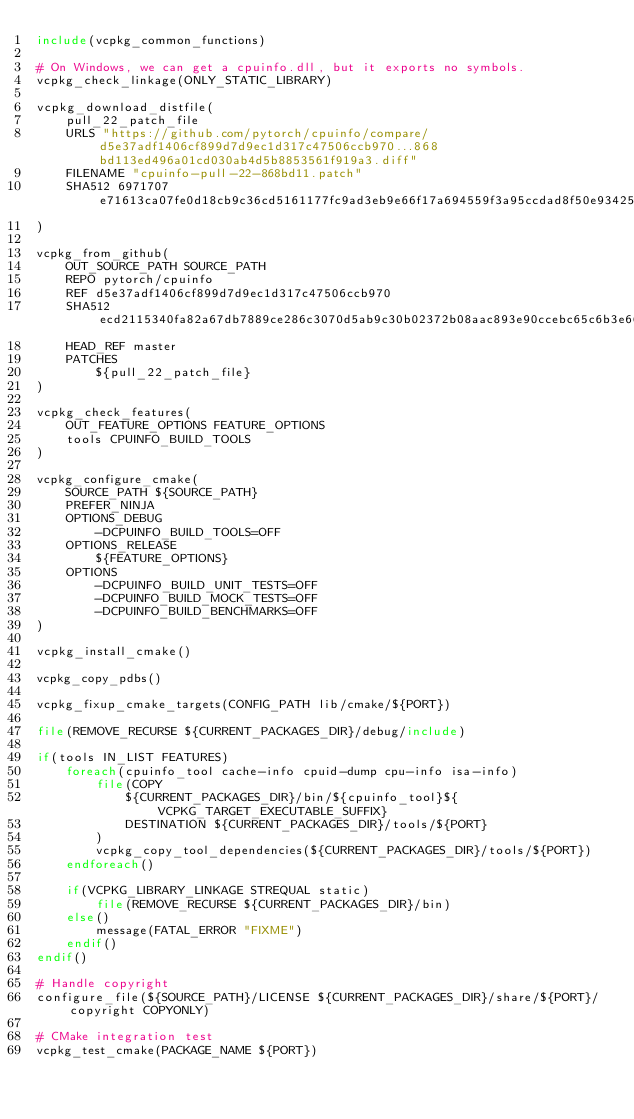Convert code to text. <code><loc_0><loc_0><loc_500><loc_500><_CMake_>include(vcpkg_common_functions)

# On Windows, we can get a cpuinfo.dll, but it exports no symbols.
vcpkg_check_linkage(ONLY_STATIC_LIBRARY)

vcpkg_download_distfile(
    pull_22_patch_file
    URLS "https://github.com/pytorch/cpuinfo/compare/d5e37adf1406cf899d7d9ec1d317c47506ccb970...868bd113ed496a01cd030ab4d5b8853561f919a3.diff"
    FILENAME "cpuinfo-pull-22-868bd11.patch"
    SHA512 6971707e71613ca07fe0d18cb9c36cd5161177fc9ad3eb9e66f17a694559f3a95ccdad8f50e9342507a7978bd454f66e47c8a94db9077267ca302535b7cc3b59
)

vcpkg_from_github(
    OUT_SOURCE_PATH SOURCE_PATH
    REPO pytorch/cpuinfo
    REF d5e37adf1406cf899d7d9ec1d317c47506ccb970
    SHA512 ecd2115340fa82a67db7889ce286c3070d5ab9c30b02372b08aac893e90ccebc65c6b3e66aa02a9ae9c57892d2d8c3b77cb836e5fc3b88df2c75d33e574d90d2
    HEAD_REF master
    PATCHES
        ${pull_22_patch_file}
)

vcpkg_check_features(
    OUT_FEATURE_OPTIONS FEATURE_OPTIONS
    tools CPUINFO_BUILD_TOOLS
)

vcpkg_configure_cmake(
    SOURCE_PATH ${SOURCE_PATH}
    PREFER_NINJA
    OPTIONS_DEBUG
        -DCPUINFO_BUILD_TOOLS=OFF
    OPTIONS_RELEASE
        ${FEATURE_OPTIONS}
    OPTIONS
        -DCPUINFO_BUILD_UNIT_TESTS=OFF
        -DCPUINFO_BUILD_MOCK_TESTS=OFF
        -DCPUINFO_BUILD_BENCHMARKS=OFF
)

vcpkg_install_cmake()

vcpkg_copy_pdbs()

vcpkg_fixup_cmake_targets(CONFIG_PATH lib/cmake/${PORT})

file(REMOVE_RECURSE ${CURRENT_PACKAGES_DIR}/debug/include)

if(tools IN_LIST FEATURES)
    foreach(cpuinfo_tool cache-info cpuid-dump cpu-info isa-info)
        file(COPY
            ${CURRENT_PACKAGES_DIR}/bin/${cpuinfo_tool}${VCPKG_TARGET_EXECUTABLE_SUFFIX}
            DESTINATION ${CURRENT_PACKAGES_DIR}/tools/${PORT}
        )
        vcpkg_copy_tool_dependencies(${CURRENT_PACKAGES_DIR}/tools/${PORT})
    endforeach()

    if(VCPKG_LIBRARY_LINKAGE STREQUAL static)
        file(REMOVE_RECURSE ${CURRENT_PACKAGES_DIR}/bin)
    else()
        message(FATAL_ERROR "FIXME")
    endif()
endif()

# Handle copyright
configure_file(${SOURCE_PATH}/LICENSE ${CURRENT_PACKAGES_DIR}/share/${PORT}/copyright COPYONLY)

# CMake integration test
vcpkg_test_cmake(PACKAGE_NAME ${PORT})
</code> 